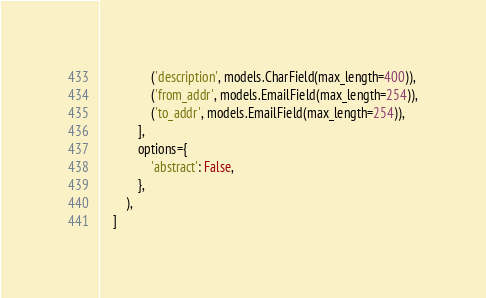<code> <loc_0><loc_0><loc_500><loc_500><_Python_>                ('description', models.CharField(max_length=400)),
                ('from_addr', models.EmailField(max_length=254)),
                ('to_addr', models.EmailField(max_length=254)),
            ],
            options={
                'abstract': False,
            },
        ),
    ]
</code> 